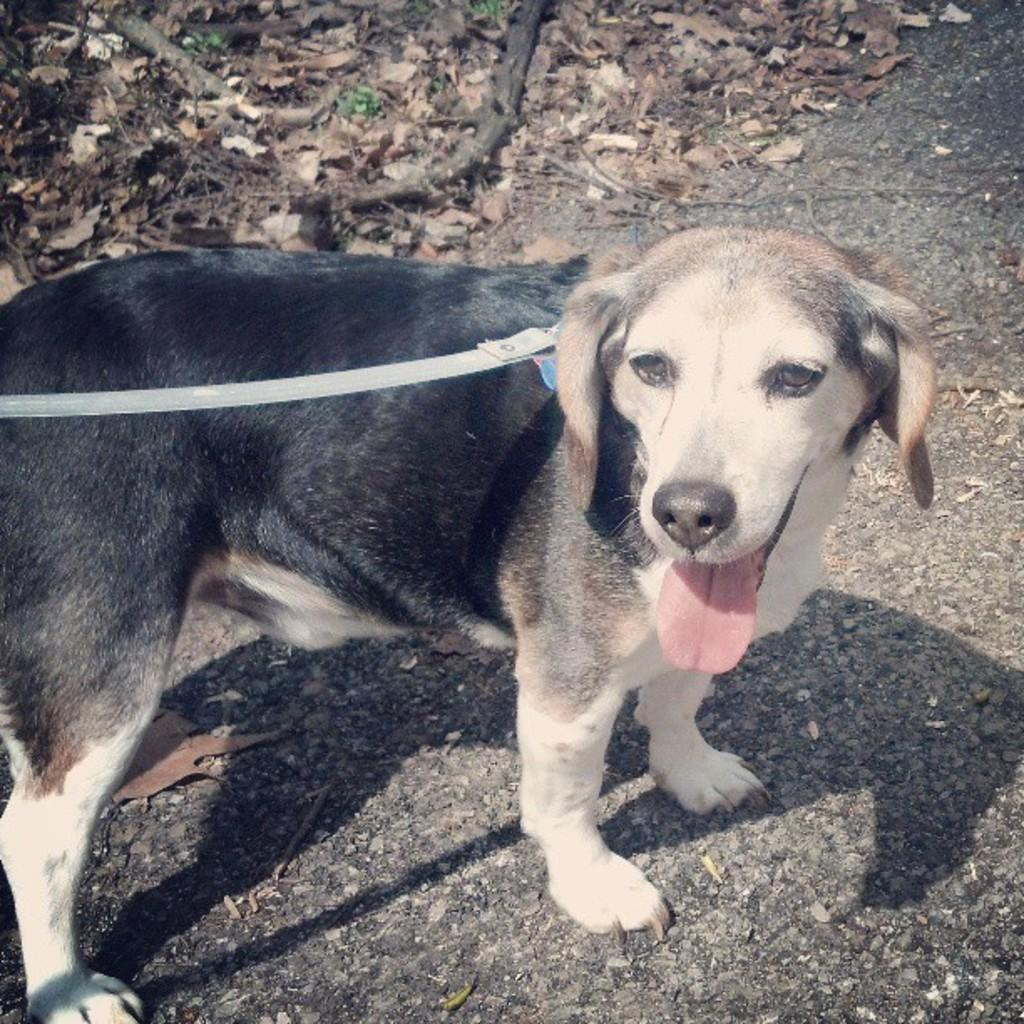What type of animal is present in the image? There is a dog in the image. What is the dog wearing? The dog is wearing a belt. Where is the dog located in the image? The dog is standing on the road. What can be seen on the ground in the background of the image? There are dried leaves and sticks on the ground in the background. What type of notebook is the dog holding in the image? There is no notebook present in the image; the dog is not holding anything. Can you describe the clam's shell in the image? There is no clam present in the image, so it is not possible to describe its shell. 